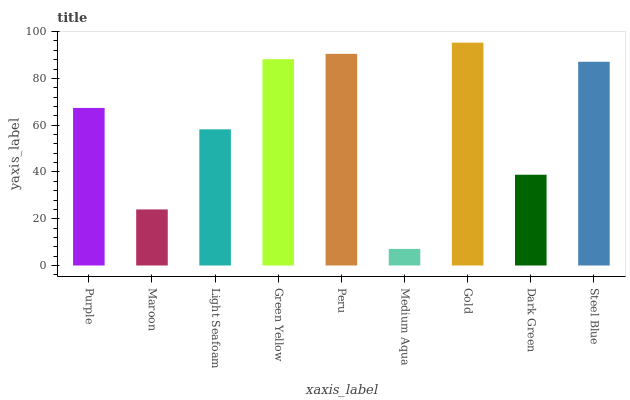Is Maroon the minimum?
Answer yes or no. No. Is Maroon the maximum?
Answer yes or no. No. Is Purple greater than Maroon?
Answer yes or no. Yes. Is Maroon less than Purple?
Answer yes or no. Yes. Is Maroon greater than Purple?
Answer yes or no. No. Is Purple less than Maroon?
Answer yes or no. No. Is Purple the high median?
Answer yes or no. Yes. Is Purple the low median?
Answer yes or no. Yes. Is Dark Green the high median?
Answer yes or no. No. Is Steel Blue the low median?
Answer yes or no. No. 